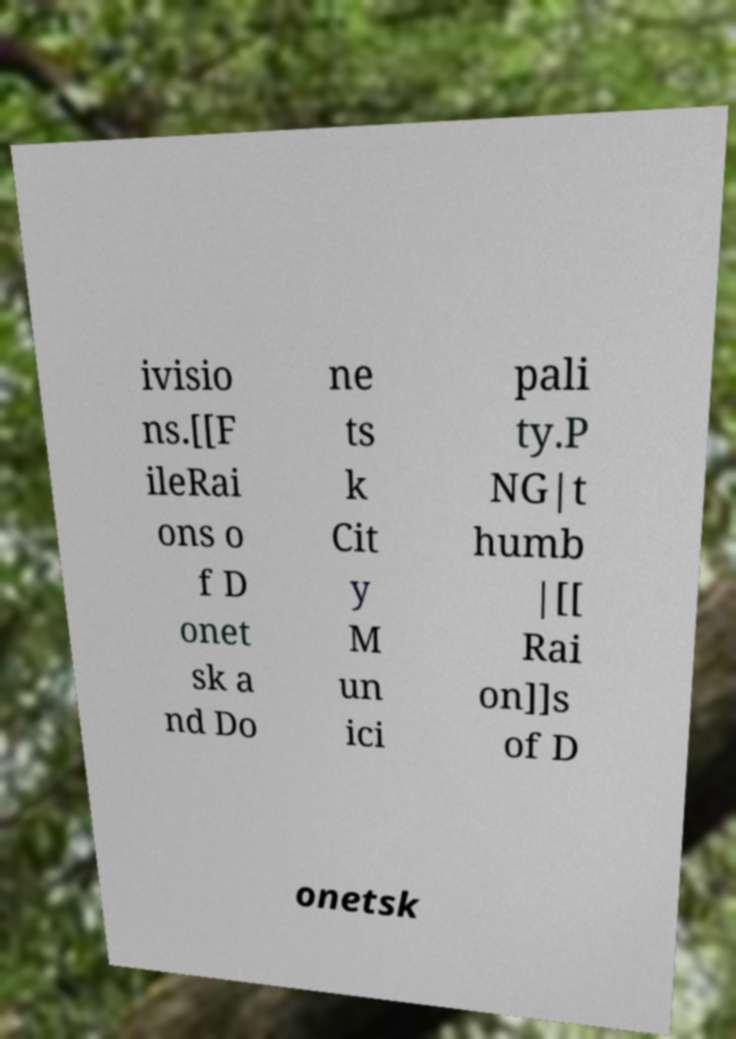For documentation purposes, I need the text within this image transcribed. Could you provide that? ivisio ns.[[F ileRai ons o f D onet sk a nd Do ne ts k Cit y M un ici pali ty.P NG|t humb |[[ Rai on]]s of D onetsk 